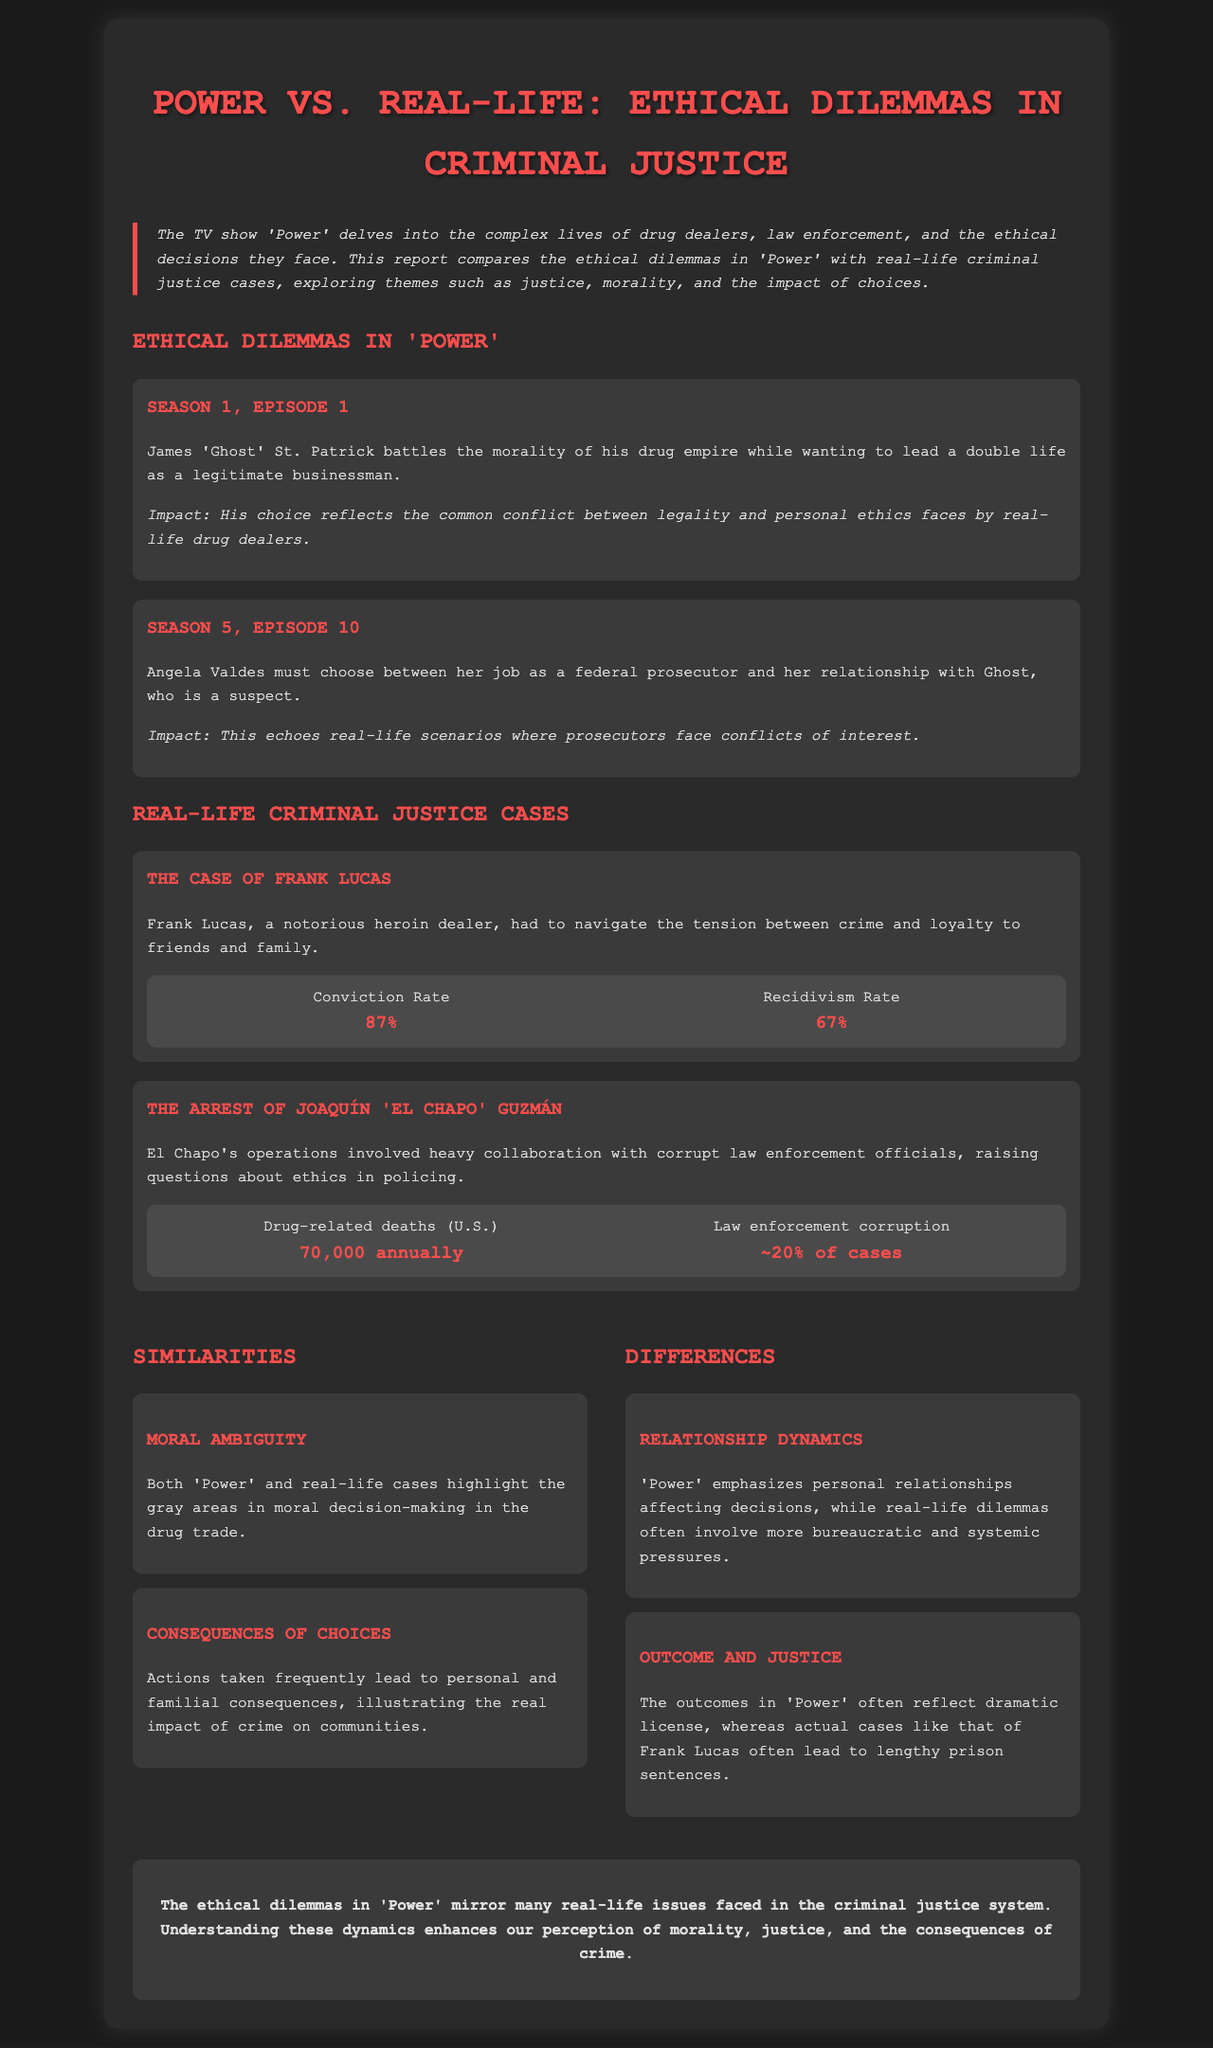What is the title of the report? The title of the report is presented in the header section, highlighting the central theme of the document.
Answer: Power vs. Real-Life: Ethical Dilemmas in Criminal Justice What is the conviction rate mentioned in Frank Lucas's case? The conviction rate is presented as a statistic in the section discussing Frank Lucas, indicating the legal outcomes of drug-related cases.
Answer: 87% Which character struggles with the morality of his drug empire in Season 1, Episode 1? This character is identified in the dilemmas outlined for the show 'Power,' detailing his internal conflict.
Answer: James 'Ghost' St. Patrick How many drug-related deaths occur annually in the U.S. according to El Chapo's case? This statistic is provided within the context of El Chapo's operations, emphasizing the serious implications of drug trafficking.
Answer: 70,000 annually What theme is highlighted as a similarity between 'Power' and real-life cases? The document delineates key themes shared by the show and real incidents, focusing on specific aspects of ethical dilemmas.
Answer: Moral Ambiguity What percentage of law enforcement cases are associated with corruption? This percentage is mentioned within the statistics of El Chapo's situation, indicating a significant challenge in law enforcement.
Answer: ~20% What is a key difference in the approach to relationship dynamics between 'Power' and real-life cases? The document contrasts personal relationships in the series with other factors in actual cases, underscoring thematic differences.
Answer: Bureaucratic and systemic pressures What impact does Angela Valdes's choice in Season 5, Episode 10 reflect? The document notes the broader implications of personal choices for those in legal professions, drawing parallels with real-life situations.
Answer: Conflicts of interest 